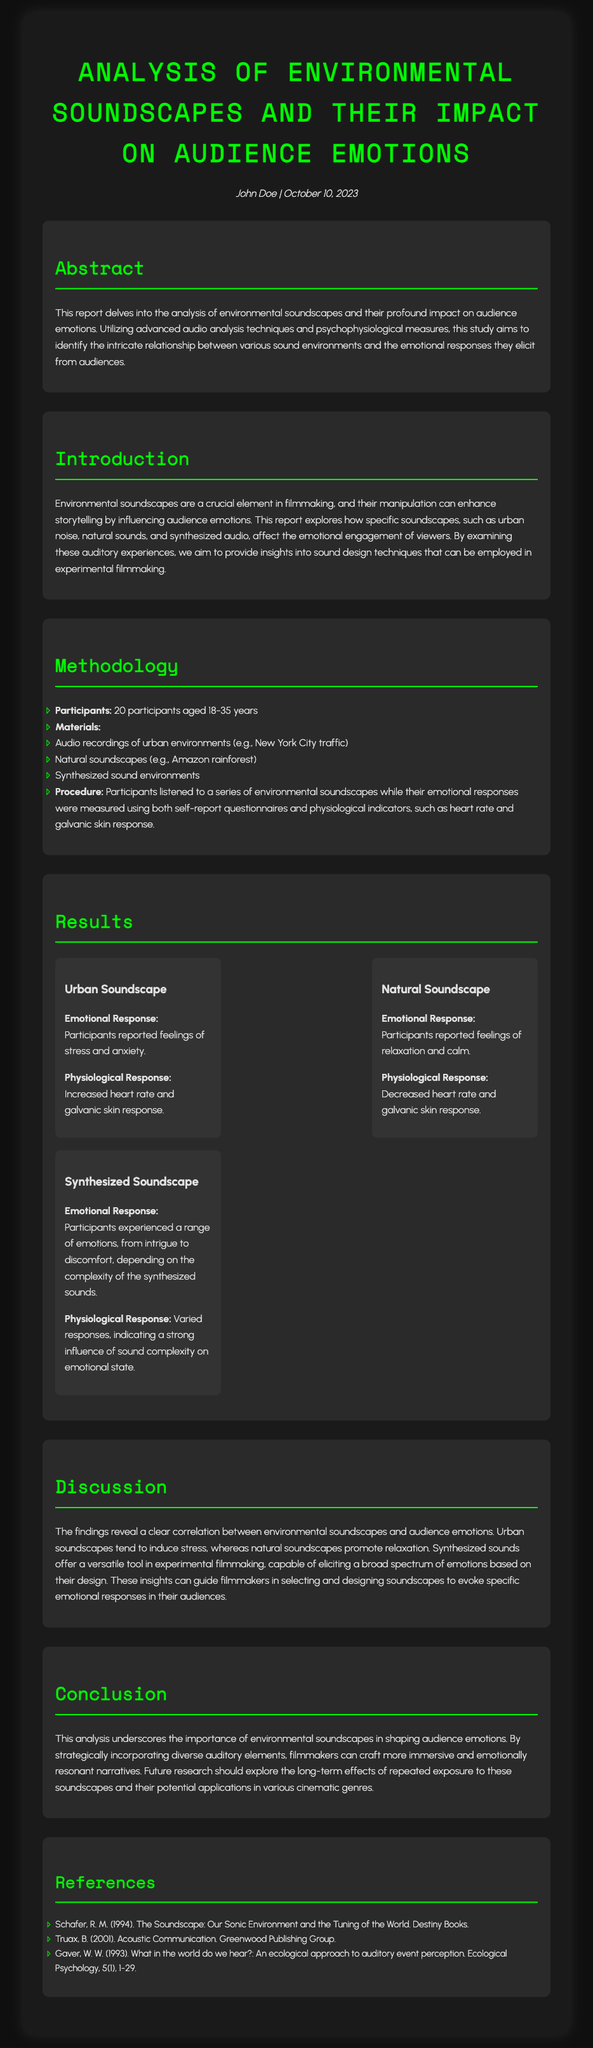What is the title of the report? The title is stated clearly at the beginning of the document.
Answer: Analysis of Environmental Soundscapes and Their Impact on Audience Emotions Who authored the report? The author's name is found in the meta section of the document.
Answer: John Doe What date was the report published? The publication date is also included in the meta section.
Answer: October 10, 2023 How many participants were involved in the study? This information is detailed in the Methodology section.
Answer: 20 participants What emotional response was reported for the Urban Soundscape? The emotional response is provided under the Results section.
Answer: Feelings of stress and anxiety What physiological response was recorded during the Natural Soundscape? The physiological response is listed in the same section.
Answer: Decreased heart rate and galvanic skin response What is the main finding regarding the Natural Soundscape? The findings are summarized in the Discussion section.
Answer: Promote relaxation Which soundscape elicited a range of emotions? The Results section describes the emotional responses to different soundscapes.
Answer: Synthesized Soundscape What future research suggestion is mentioned? The conclusion includes suggestions for future studies.
Answer: Long-term effects of repeated exposure to these soundscapes 